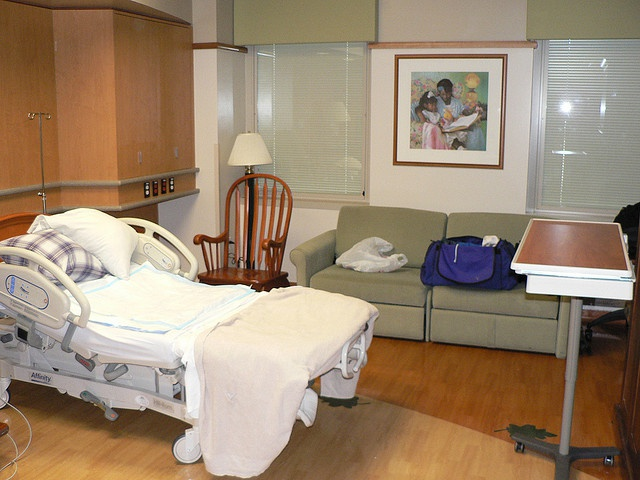Describe the objects in this image and their specific colors. I can see bed in maroon, ivory, darkgray, and tan tones, couch in maroon, gray, and navy tones, chair in maroon, brown, gray, and black tones, and suitcase in maroon, navy, black, and gray tones in this image. 